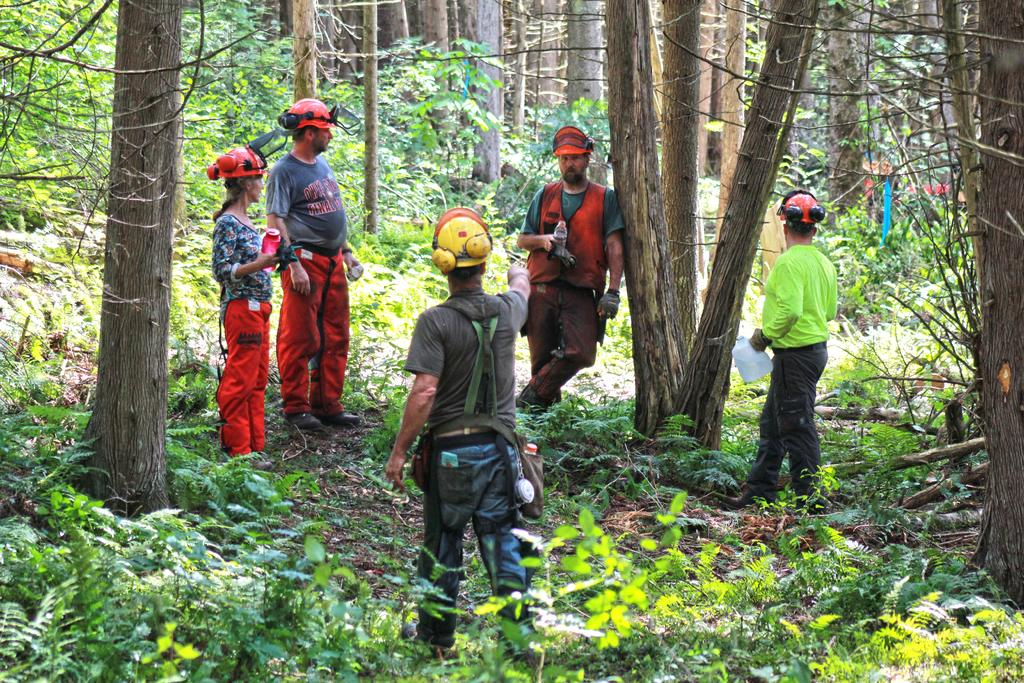What type of living organisms can be seen in the image? Plants and trees are visible in the image. Are there any human subjects in the image? Yes, there are people standing in the image. What type of vase is being argued over by the people in the image? There is no vase or argument present in the image; it features plants, trees, and people standing. 